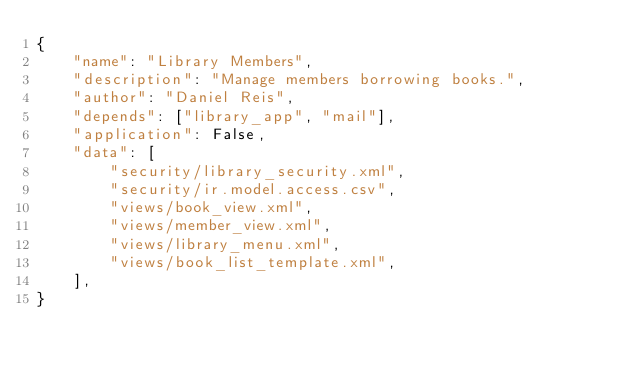<code> <loc_0><loc_0><loc_500><loc_500><_Python_>{
    "name": "Library Members",
    "description": "Manage members borrowing books.",
    "author": "Daniel Reis",
    "depends": ["library_app", "mail"],
    "application": False,
    "data": [
        "security/library_security.xml",
        "security/ir.model.access.csv",
        "views/book_view.xml",
        "views/member_view.xml",
        "views/library_menu.xml",
        "views/book_list_template.xml",
    ],
}
</code> 